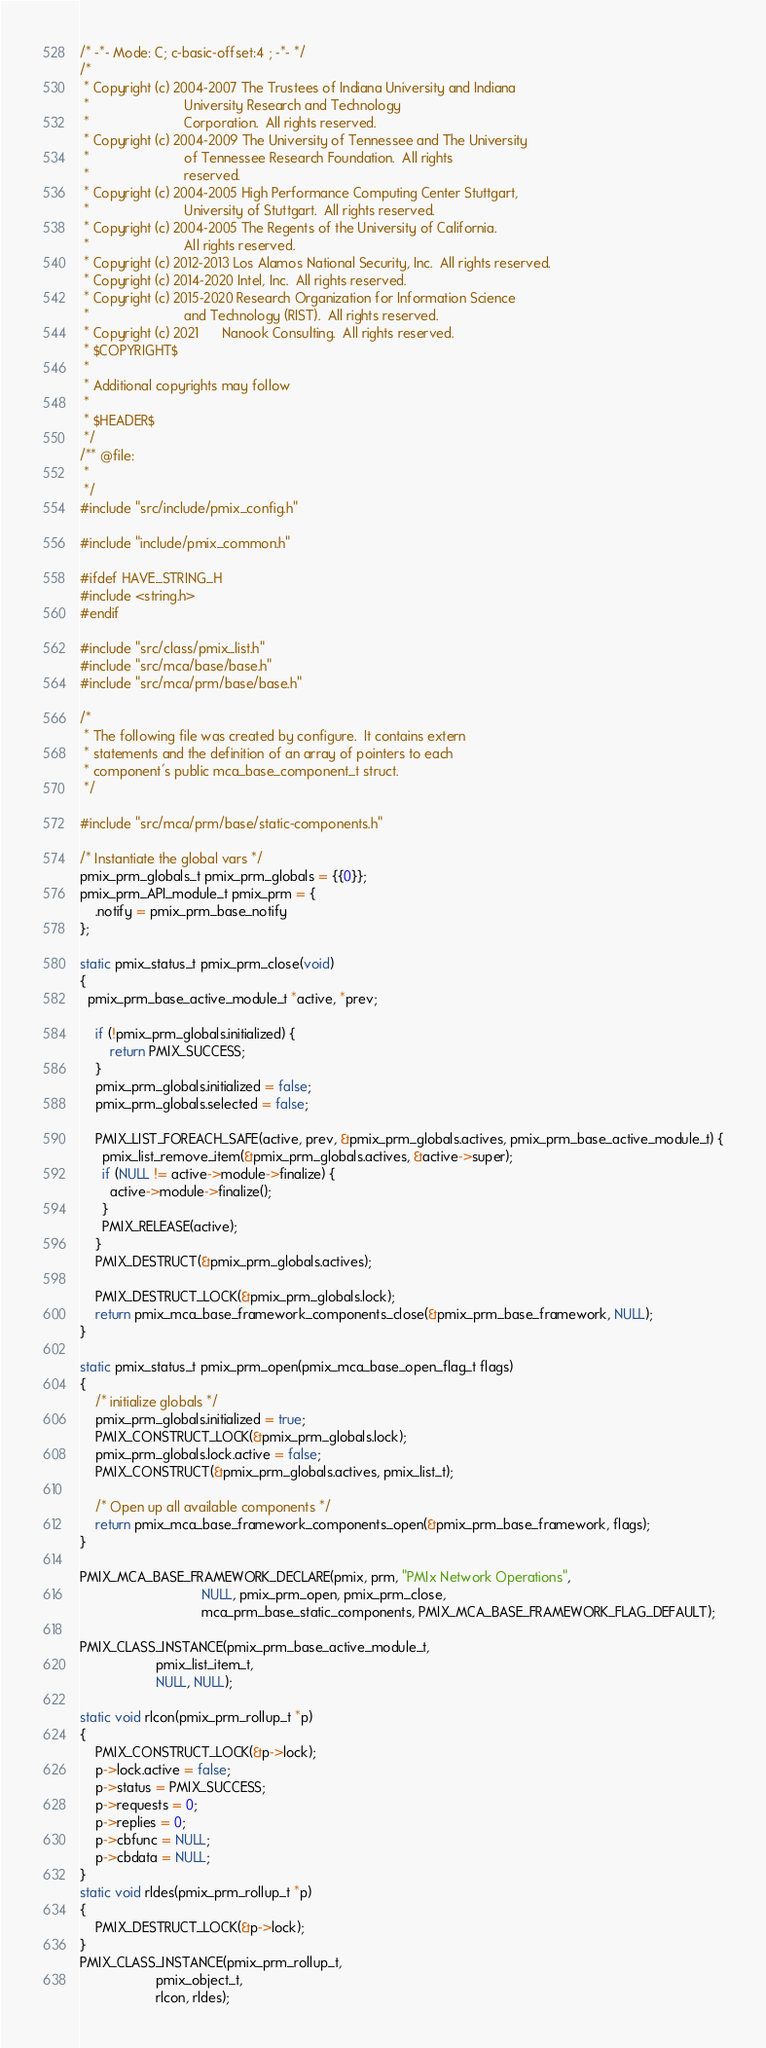Convert code to text. <code><loc_0><loc_0><loc_500><loc_500><_C_>/* -*- Mode: C; c-basic-offset:4 ; -*- */
/*
 * Copyright (c) 2004-2007 The Trustees of Indiana University and Indiana
 *                         University Research and Technology
 *                         Corporation.  All rights reserved.
 * Copyright (c) 2004-2009 The University of Tennessee and The University
 *                         of Tennessee Research Foundation.  All rights
 *                         reserved.
 * Copyright (c) 2004-2005 High Performance Computing Center Stuttgart,
 *                         University of Stuttgart.  All rights reserved.
 * Copyright (c) 2004-2005 The Regents of the University of California.
 *                         All rights reserved.
 * Copyright (c) 2012-2013 Los Alamos National Security, Inc.  All rights reserved.
 * Copyright (c) 2014-2020 Intel, Inc.  All rights reserved.
 * Copyright (c) 2015-2020 Research Organization for Information Science
 *                         and Technology (RIST).  All rights reserved.
 * Copyright (c) 2021      Nanook Consulting.  All rights reserved.
 * $COPYRIGHT$
 *
 * Additional copyrights may follow
 *
 * $HEADER$
 */
/** @file:
 *
 */
#include "src/include/pmix_config.h"

#include "include/pmix_common.h"

#ifdef HAVE_STRING_H
#include <string.h>
#endif

#include "src/class/pmix_list.h"
#include "src/mca/base/base.h"
#include "src/mca/prm/base/base.h"

/*
 * The following file was created by configure.  It contains extern
 * statements and the definition of an array of pointers to each
 * component's public mca_base_component_t struct.
 */

#include "src/mca/prm/base/static-components.h"

/* Instantiate the global vars */
pmix_prm_globals_t pmix_prm_globals = {{0}};
pmix_prm_API_module_t pmix_prm = {
    .notify = pmix_prm_base_notify
};

static pmix_status_t pmix_prm_close(void)
{
  pmix_prm_base_active_module_t *active, *prev;

    if (!pmix_prm_globals.initialized) {
        return PMIX_SUCCESS;
    }
    pmix_prm_globals.initialized = false;
    pmix_prm_globals.selected = false;

    PMIX_LIST_FOREACH_SAFE(active, prev, &pmix_prm_globals.actives, pmix_prm_base_active_module_t) {
      pmix_list_remove_item(&pmix_prm_globals.actives, &active->super);
      if (NULL != active->module->finalize) {
        active->module->finalize();
      }
      PMIX_RELEASE(active);
    }
    PMIX_DESTRUCT(&pmix_prm_globals.actives);

    PMIX_DESTRUCT_LOCK(&pmix_prm_globals.lock);
    return pmix_mca_base_framework_components_close(&pmix_prm_base_framework, NULL);
}

static pmix_status_t pmix_prm_open(pmix_mca_base_open_flag_t flags)
{
    /* initialize globals */
    pmix_prm_globals.initialized = true;
    PMIX_CONSTRUCT_LOCK(&pmix_prm_globals.lock);
    pmix_prm_globals.lock.active = false;
    PMIX_CONSTRUCT(&pmix_prm_globals.actives, pmix_list_t);

    /* Open up all available components */
    return pmix_mca_base_framework_components_open(&pmix_prm_base_framework, flags);
}

PMIX_MCA_BASE_FRAMEWORK_DECLARE(pmix, prm, "PMIx Network Operations",
                                NULL, pmix_prm_open, pmix_prm_close,
                                mca_prm_base_static_components, PMIX_MCA_BASE_FRAMEWORK_FLAG_DEFAULT);

PMIX_CLASS_INSTANCE(pmix_prm_base_active_module_t,
                    pmix_list_item_t,
                    NULL, NULL);

static void rlcon(pmix_prm_rollup_t *p)
{
    PMIX_CONSTRUCT_LOCK(&p->lock);
    p->lock.active = false;
    p->status = PMIX_SUCCESS;
    p->requests = 0;
    p->replies = 0;
    p->cbfunc = NULL;
    p->cbdata = NULL;
}
static void rldes(pmix_prm_rollup_t *p)
{
    PMIX_DESTRUCT_LOCK(&p->lock);
}
PMIX_CLASS_INSTANCE(pmix_prm_rollup_t,
                    pmix_object_t,
                    rlcon, rldes);
</code> 